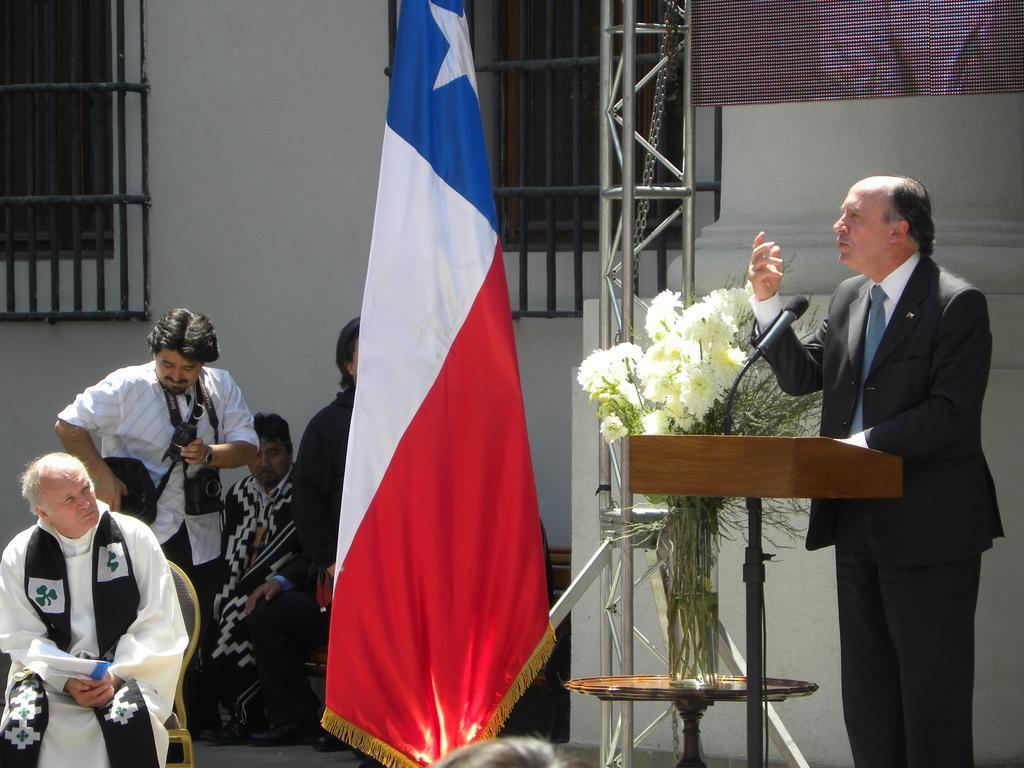Can you describe this image briefly? On the right side there is a person standing and talking. In front of him there is a stand with mic. Near to that there is a stand. Also there is a flag. On the left side there is a person sitting on the chair. In the back there are many people. In the background there is a building with windows. 